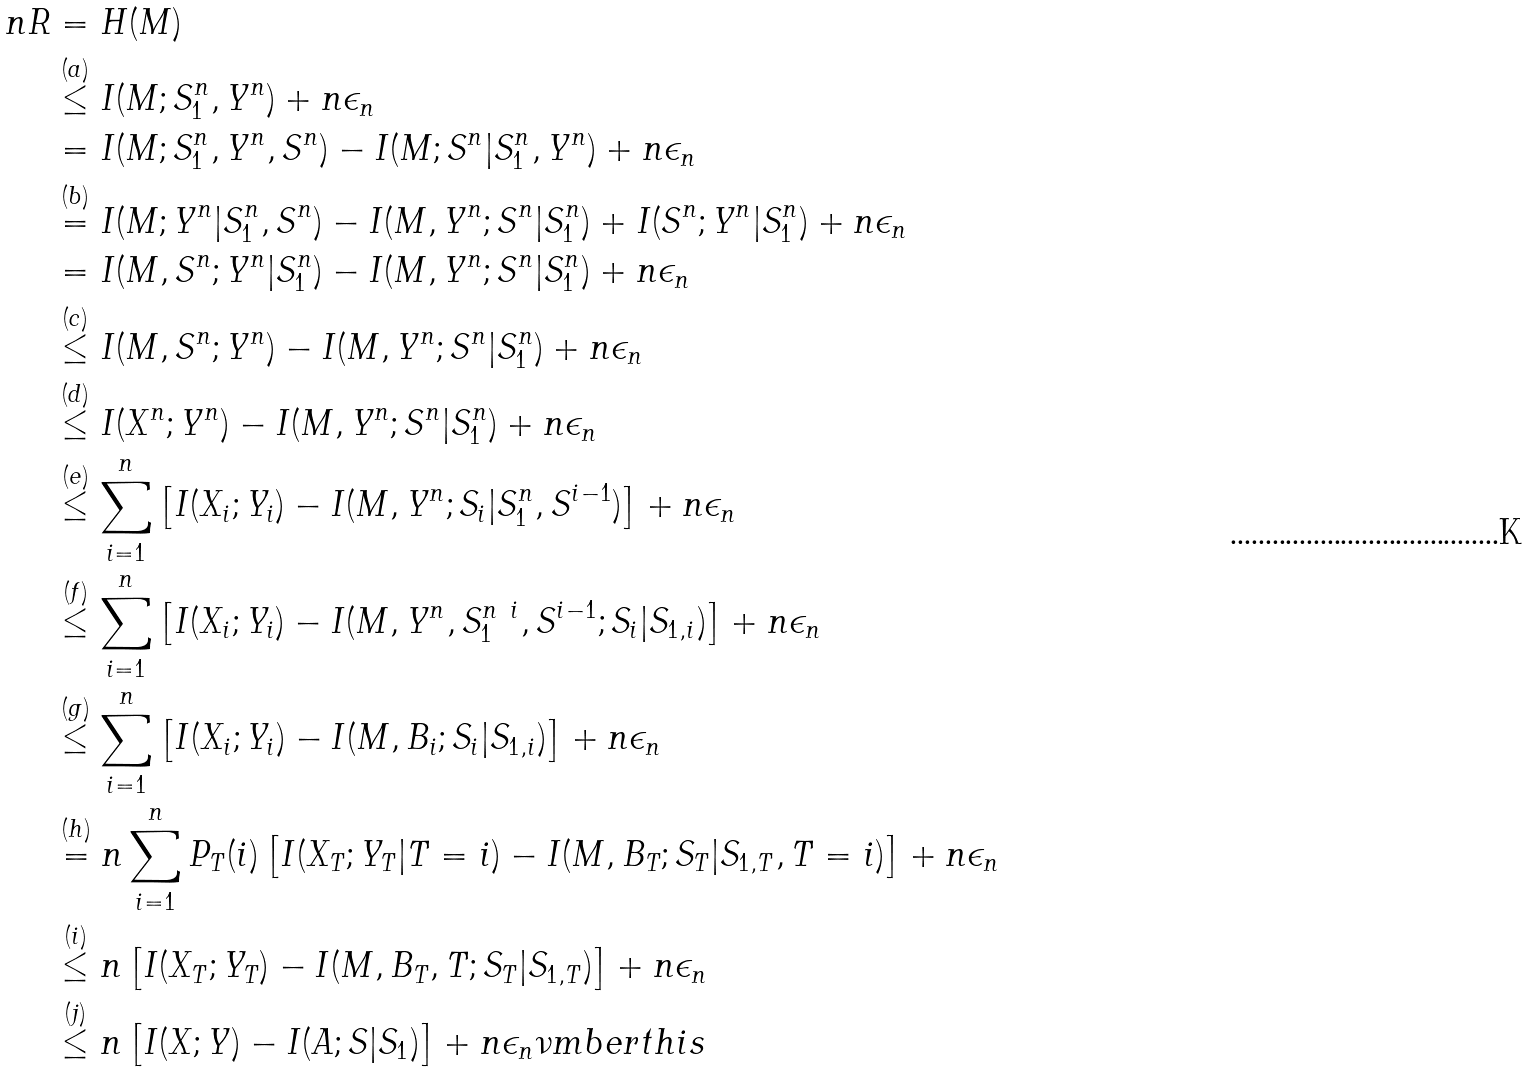Convert formula to latex. <formula><loc_0><loc_0><loc_500><loc_500>n R & = H ( M ) \\ & \stackrel { ( a ) } \leq I ( M ; S _ { 1 } ^ { n } , Y ^ { n } ) + n \epsilon _ { n } \\ & = I ( M ; S _ { 1 } ^ { n } , Y ^ { n } , S ^ { n } ) - I ( M ; S ^ { n } | S _ { 1 } ^ { n } , Y ^ { n } ) + n \epsilon _ { n } \\ & \stackrel { ( b ) } = I ( M ; Y ^ { n } | S _ { 1 } ^ { n } , S ^ { n } ) - I ( M , Y ^ { n } ; S ^ { n } | S _ { 1 } ^ { n } ) + I ( S ^ { n } ; Y ^ { n } | S _ { 1 } ^ { n } ) + n \epsilon _ { n } \\ & = I ( M , S ^ { n } ; Y ^ { n } | S _ { 1 } ^ { n } ) - I ( M , Y ^ { n } ; S ^ { n } | S _ { 1 } ^ { n } ) + n \epsilon _ { n } \\ & \stackrel { ( c ) } \leq I ( M , S ^ { n } ; Y ^ { n } ) - I ( M , Y ^ { n } ; S ^ { n } | S _ { 1 } ^ { n } ) + n \epsilon _ { n } \\ & \stackrel { ( d ) } \leq I ( X ^ { n } ; Y ^ { n } ) - I ( M , Y ^ { n } ; S ^ { n } | S _ { 1 } ^ { n } ) + n \epsilon _ { n } \\ & \stackrel { ( e ) } \leq \sum _ { i = 1 } ^ { n } \left [ I ( X _ { i } ; Y _ { i } ) - I ( M , Y ^ { n } ; S _ { i } | S _ { 1 } ^ { n } , S ^ { i - 1 } ) \right ] + n \epsilon _ { n } \\ & \stackrel { ( f ) } \leq \sum _ { i = 1 } ^ { n } \left [ I ( X _ { i } ; Y _ { i } ) - I ( M , Y ^ { n } , S _ { 1 } ^ { n \ i } , S ^ { i - 1 } ; S _ { i } | S _ { 1 , i } ) \right ] + n \epsilon _ { n } \\ & \stackrel { ( g ) } \leq \sum _ { i = 1 } ^ { n } \left [ I ( X _ { i } ; Y _ { i } ) - I ( M , B _ { i } ; S _ { i } | S _ { 1 , i } ) \right ] + n \epsilon _ { n } \\ & \stackrel { ( h ) } = n \sum _ { i = 1 } ^ { n } P _ { T } ( i ) \left [ I ( X _ { T } ; Y _ { T } | T = i ) - I ( M , B _ { T } ; S _ { T } | S _ { 1 , T } , T = i ) \right ] + n \epsilon _ { n } \\ & \stackrel { ( i ) } \leq n \left [ I ( X _ { T } ; Y _ { T } ) - I ( M , B _ { T } , T ; S _ { T } | S _ { 1 , T } ) \right ] + n \epsilon _ { n } \\ & \stackrel { ( j ) } \leq n \left [ I ( X ; Y ) - I ( A ; S | S _ { 1 } ) \right ] + n \epsilon _ { n } \nu m b e r t h i s</formula> 